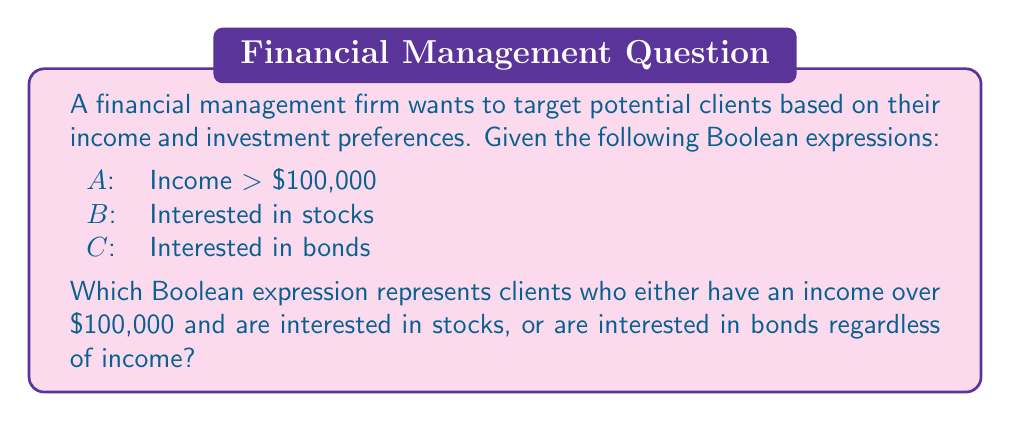Provide a solution to this math problem. To solve this problem, we need to break it down into two parts and then combine them using Boolean operators:

1. Clients with income over $100,000 and interested in stocks:
   This can be represented as $A \wedge B$

2. Clients interested in bonds regardless of income:
   This is simply represented as $C$

Now, we need to combine these two conditions using the OR operator, as we want clients who satisfy either of these conditions:

$(A \wedge B) \vee C$

This Boolean expression accurately represents the target group:
- $(A \wedge B)$ captures high-income clients interested in stocks
- $C$ captures all clients interested in bonds, regardless of their income
- The $\vee$ (OR) operator ensures we include both groups

In the context of financial management, this Boolean expression allows us to efficiently segment the market and identify potential clients who match our criteria, enabling more targeted marketing strategies and personalized financial services.
Answer: $(A \wedge B) \vee C$ 